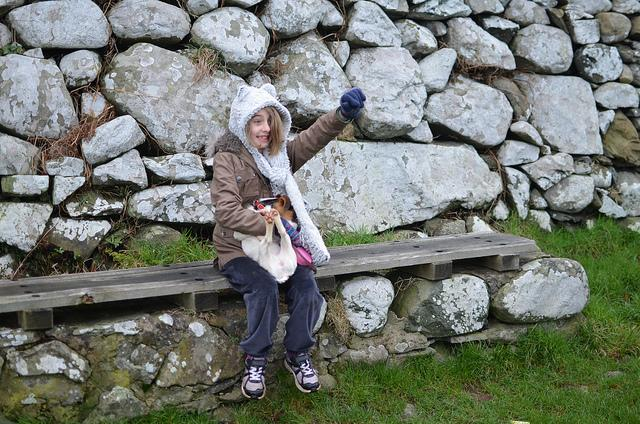What is it called when walls are built without mortar? Please explain your reasoning. dry stone. When walls are built without mortar it's called dry stone. 